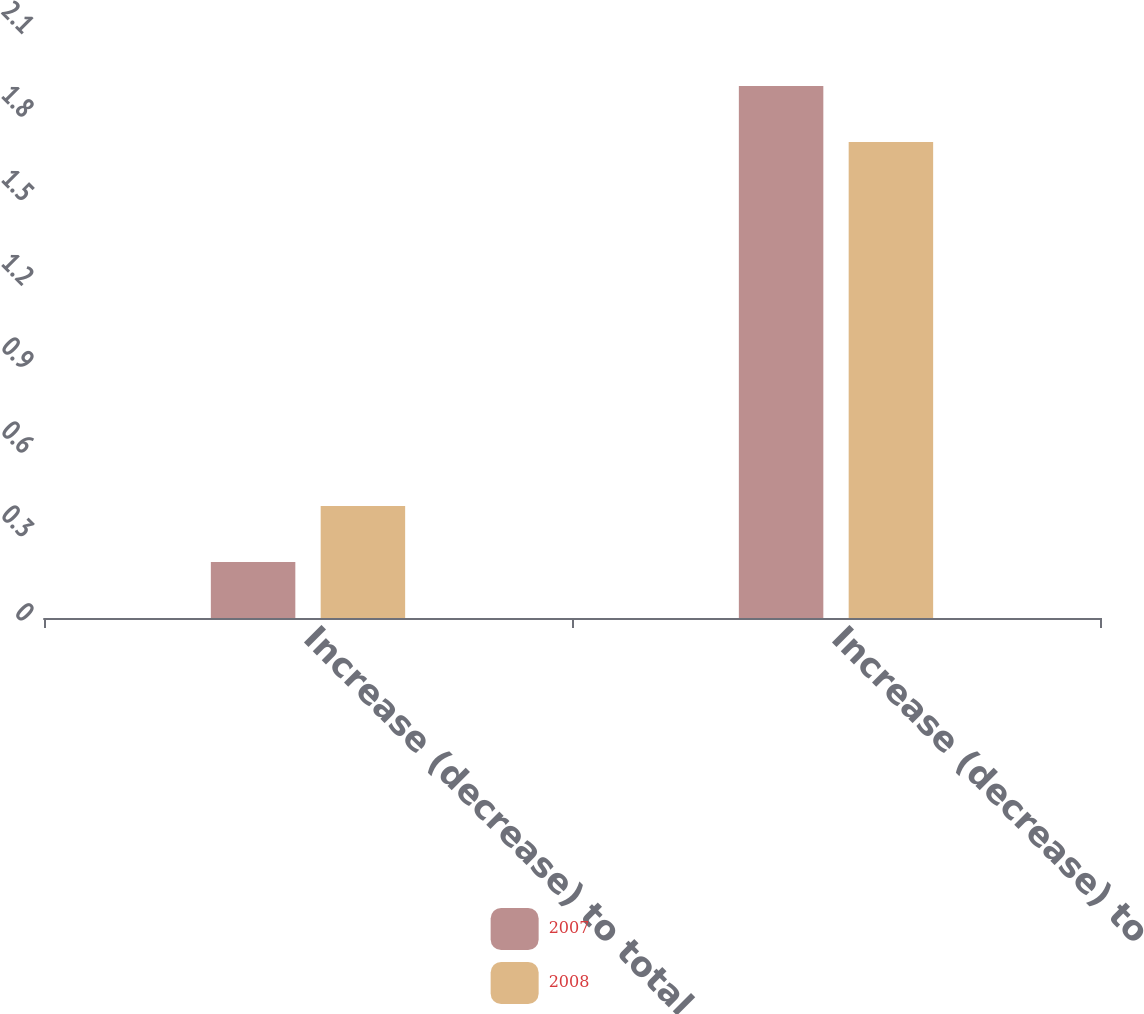Convert chart to OTSL. <chart><loc_0><loc_0><loc_500><loc_500><stacked_bar_chart><ecel><fcel>Increase (decrease) to total<fcel>Increase (decrease) to<nl><fcel>2007<fcel>0.2<fcel>1.9<nl><fcel>2008<fcel>0.4<fcel>1.7<nl></chart> 